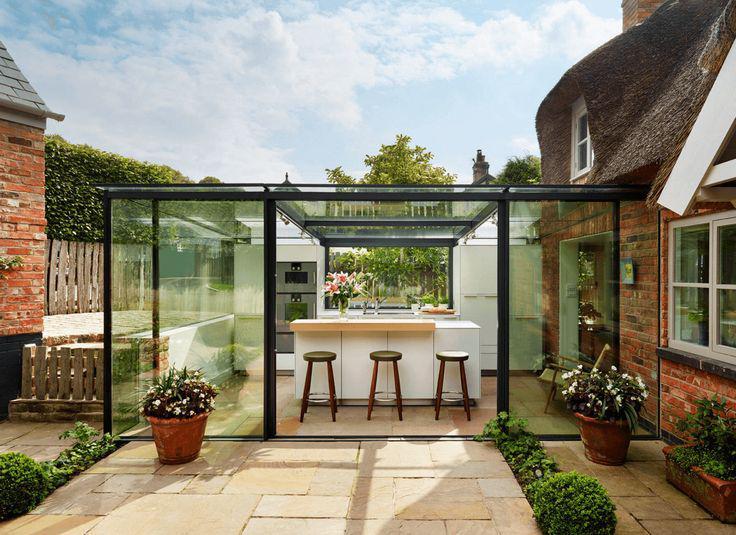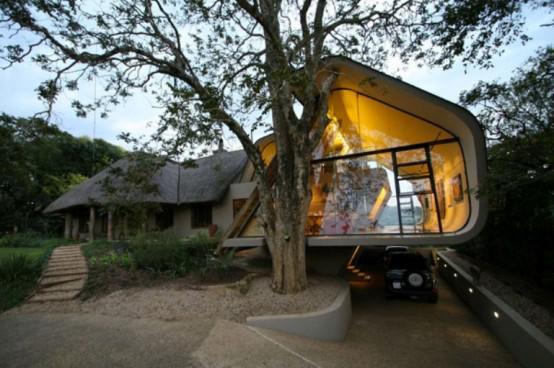The first image is the image on the left, the second image is the image on the right. Evaluate the accuracy of this statement regarding the images: "An image shows a white house with a grayish-brown roof that curves around and over a window.". Is it true? Answer yes or no. No. The first image is the image on the left, the second image is the image on the right. Evaluate the accuracy of this statement regarding the images: "in at least one image there is a house with a gray roof slanted facing left.". Is it true? Answer yes or no. Yes. 